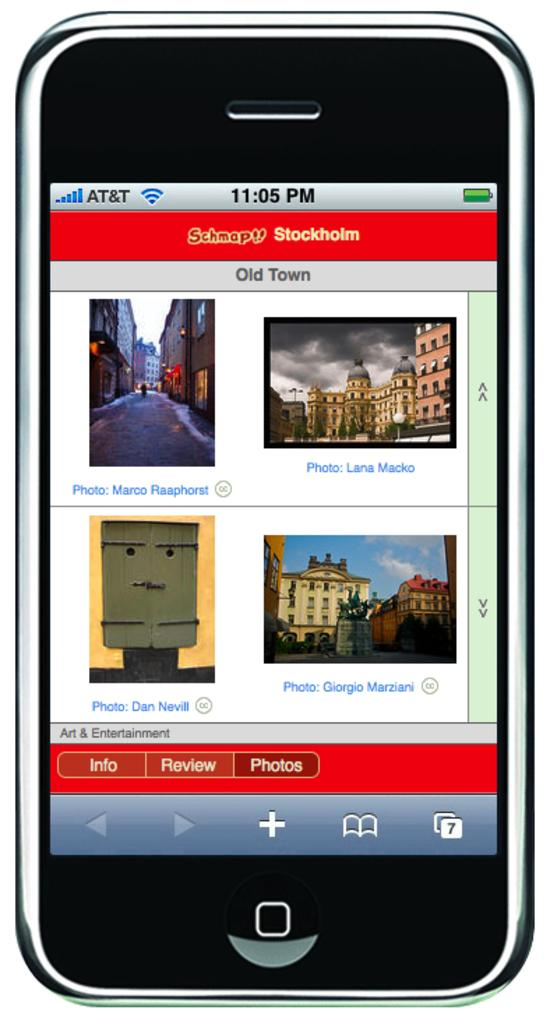Provide a one-sentence caption for the provided image. an iphone with the screen on and time reading 11:05 pm. 